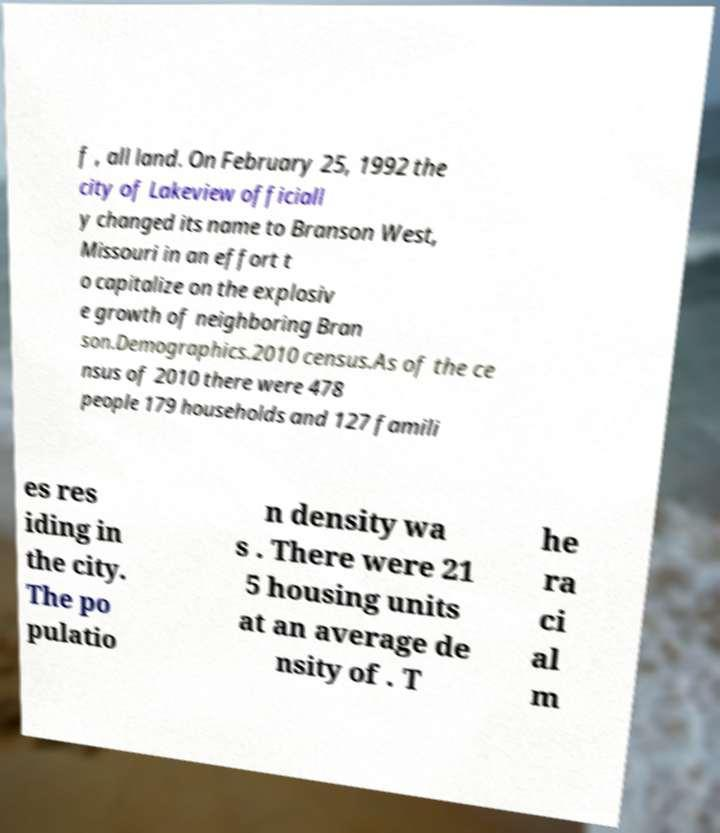Please read and relay the text visible in this image. What does it say? f , all land. On February 25, 1992 the city of Lakeview officiall y changed its name to Branson West, Missouri in an effort t o capitalize on the explosiv e growth of neighboring Bran son.Demographics.2010 census.As of the ce nsus of 2010 there were 478 people 179 households and 127 famili es res iding in the city. The po pulatio n density wa s . There were 21 5 housing units at an average de nsity of . T he ra ci al m 